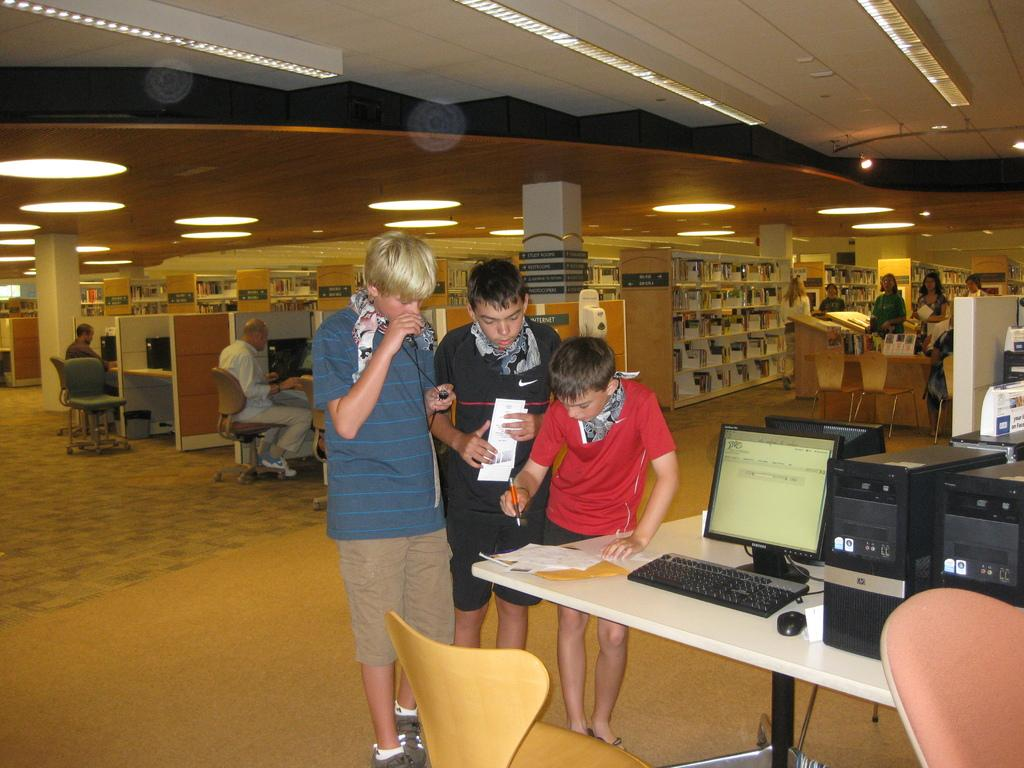What are the people in the image doing? Some people are standing, while others are seated in the image. What can be seen on the wall in the image? There is a bookshelf on the wall in the image. What is on the table in the image? There is a monitor on a table in the image. What verse is being recited by the people in the image? There is no verse being recited in the image; the people are standing and seated, but no activity involving a verse is depicted. 